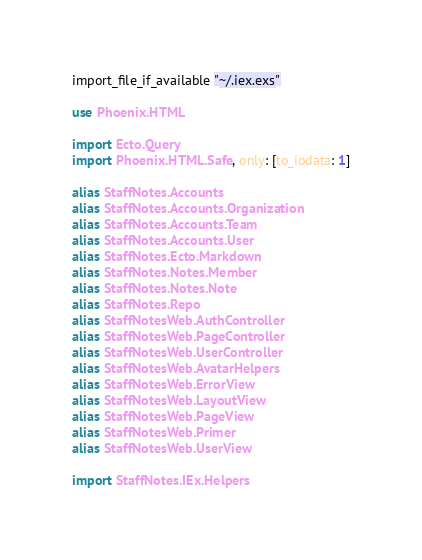<code> <loc_0><loc_0><loc_500><loc_500><_Elixir_>import_file_if_available "~/.iex.exs"

use Phoenix.HTML

import Ecto.Query
import Phoenix.HTML.Safe, only: [to_iodata: 1]

alias StaffNotes.Accounts
alias StaffNotes.Accounts.Organization
alias StaffNotes.Accounts.Team
alias StaffNotes.Accounts.User
alias StaffNotes.Ecto.Markdown
alias StaffNotes.Notes.Member
alias StaffNotes.Notes.Note
alias StaffNotes.Repo
alias StaffNotesWeb.AuthController
alias StaffNotesWeb.PageController
alias StaffNotesWeb.UserController
alias StaffNotesWeb.AvatarHelpers
alias StaffNotesWeb.ErrorView
alias StaffNotesWeb.LayoutView
alias StaffNotesWeb.PageView
alias StaffNotesWeb.Primer
alias StaffNotesWeb.UserView

import StaffNotes.IEx.Helpers
</code> 